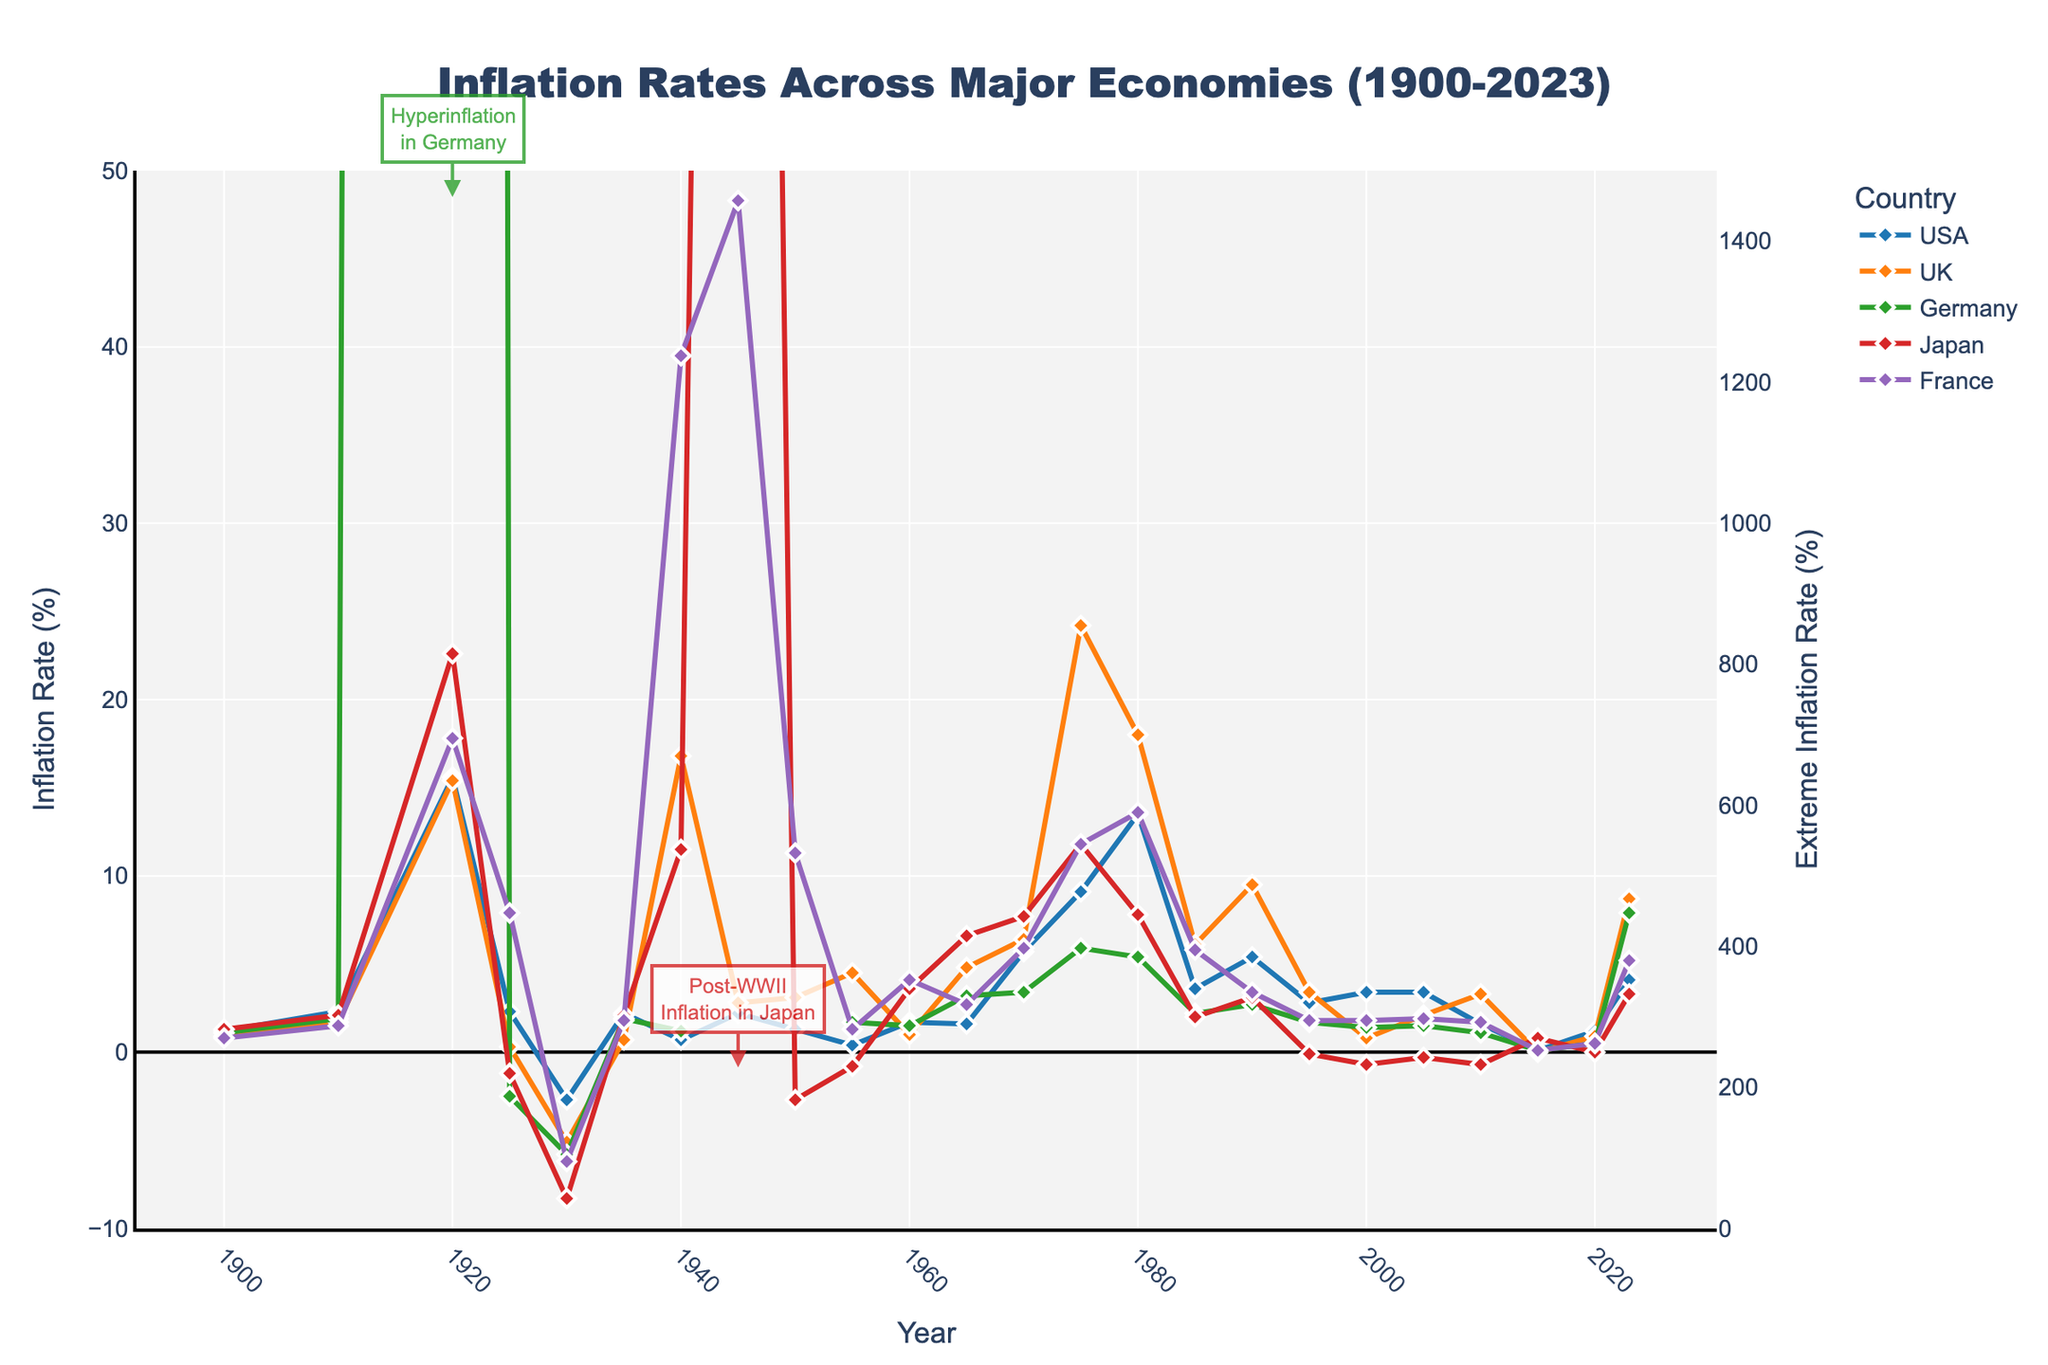What major historical events are marked with high inflation rates in the figure? The figure annotates specific points where hyperinflation and high inflation occurred. In 1920, Germany experiences hyperinflation due to post-WWI economic conditions. Post-WWII inflation in 1945 Japan is also annotated. These points are highlighted with numeric and textual annotations.
Answer: Hyperinflation in Germany (1920), Post-WWII inflation in Japan (1945) How did inflation rates in the UK change from 1930 to 1980? According to the chart, the UK's inflation rate was -5.1% in 1930 during the Great Depression, increased to 16.8% in 1940 (during WWII), lowered again by 1950, and then peaked to 24.2% around 1975 before stabilizing to 18.0% in 1980.
Answer: From -5.1% in 1930 to 18.0% in 1980 Which country had the most extreme inflation rate in the plotted period? Visual observation of the figure shows that Germany had the most extreme inflation rate, peaking at about 1462.5% in 1920. This is far higher than any inflation rates recorded for other countries on the chart.
Answer: Germany What are the trends in inflation rates for Japan from 1900 to 2023? Japan shows moderate inflation in the early 20th century, extreme inflation around 1945 post-WWII, negative rates around the 1950s, a peak again in the 1970s, and finally stabilization around the late 20th and early 21st century, ending with a low rate of 3.3% in 2023.
Answer: Moderate early, extreme in 1945, negative 1950s, peak 1970s, stable late 20th/early 21st In what years did the USA experience its highest and lowest inflation rates according to the figure? Observing the figure, the highest inflation rate for the USA was in 1980 at 13.5%. The lowest was around 1930 during the Great Depression, with a rate of -2.7%.
Answer: Highest in 1980, lowest in 1930 How did the inflation rate in France compare with that in the USA in 1940? France had a significantly higher inflation rate in 1940 compared to the USA. The figure indicates France at 39.5% and the USA at 0.7%, showing a substantial difference.
Answer: France much higher (39.5%) compared to the USA (0.7%) What was the inflation trend across these economies during the 1970s oil crisis? The 1970s shows a spike in inflation rates for all observed economies. The USA, UK, Germany, Japan, and France all experienced increased rates. The chart demonstrates this with notable rises around the mid-1970s.
Answer: Increased inflation for all economies Compare the average inflation rates of the UK and France from 1960 to 1980. Between 1960 to 1980, summing up the inflation rates and dividing by the number of years for the UK (1.0, 4.8, 6.4, 24.2, 18.0) and France (4.1, 2.7, 5.9, 11.8, 13.6) gives averages. UK: (1.0 + 4.8 + 6.4 + 24.2 + 18.0)/5 = 10.88%, France: (4.1 + 2.7 + 5.9 + 11.8 + 13.6)/5 = 7.62%.
Answer: UK: 10.88%, France: 7.62% By 2023, which country had the lowest inflation rate according to the figure? Observing the final data points for 2023, Japan has the lowest inflation rate at 3.3%. Other countries have higher rates (UK at 8.7%, USA at 4.1%, Germany at 7.9%, France at 5.2%).
Answer: Japan (3.3%) What is the relationship between WWII and the inflation rates across the major economies? The figure shows marked inflation increases around the WWII period. The UK in the early 1940s, Japan post-WWII with extremely high rates, and moderate increases for the USA and France are visible. Most notably, Japan's inflation shoots up to 228.4% in 1945, indicating a direct relationship with wartime conditions.
Answer: Significant increases, especially in Japan 